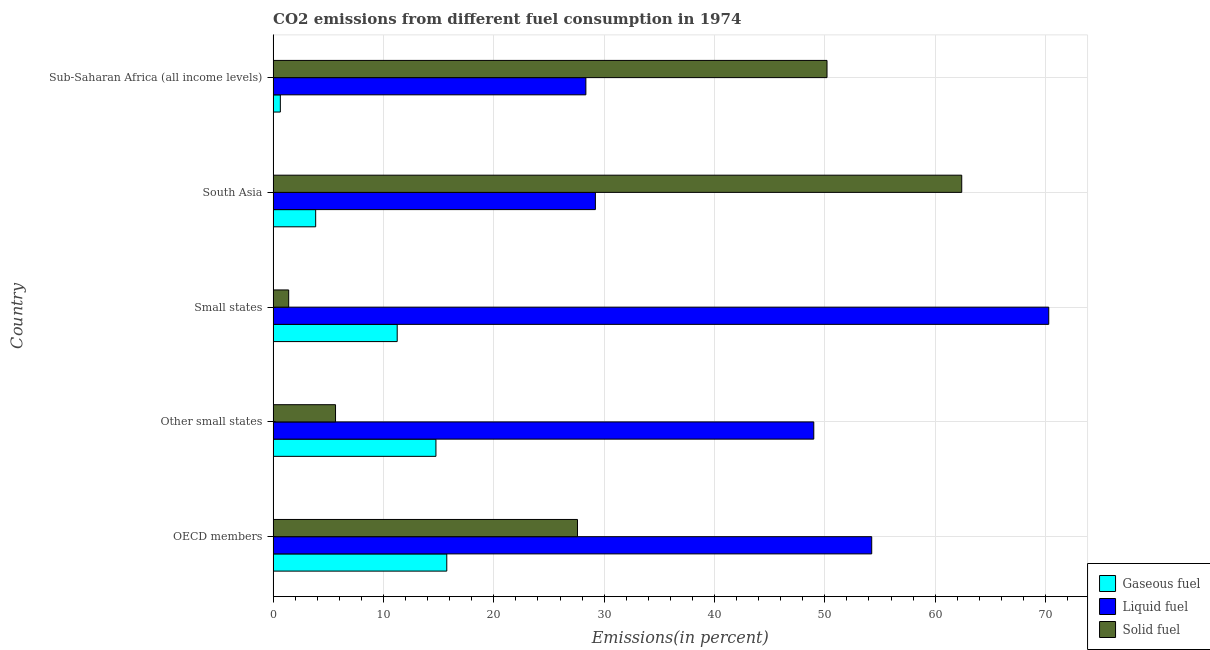How many different coloured bars are there?
Your response must be concise. 3. Are the number of bars per tick equal to the number of legend labels?
Your answer should be very brief. Yes. How many bars are there on the 3rd tick from the top?
Provide a short and direct response. 3. What is the label of the 4th group of bars from the top?
Make the answer very short. Other small states. What is the percentage of liquid fuel emission in Small states?
Your answer should be compact. 70.29. Across all countries, what is the maximum percentage of solid fuel emission?
Your answer should be very brief. 62.4. Across all countries, what is the minimum percentage of liquid fuel emission?
Your answer should be very brief. 28.34. In which country was the percentage of liquid fuel emission maximum?
Keep it short and to the point. Small states. In which country was the percentage of solid fuel emission minimum?
Offer a terse response. Small states. What is the total percentage of solid fuel emission in the graph?
Keep it short and to the point. 147.25. What is the difference between the percentage of liquid fuel emission in Small states and that in South Asia?
Ensure brevity in your answer.  41.09. What is the difference between the percentage of gaseous fuel emission in Small states and the percentage of solid fuel emission in Other small states?
Offer a very short reply. 5.59. What is the average percentage of liquid fuel emission per country?
Your response must be concise. 46.22. What is the difference between the percentage of liquid fuel emission and percentage of solid fuel emission in Sub-Saharan Africa (all income levels)?
Make the answer very short. -21.85. What is the ratio of the percentage of solid fuel emission in Other small states to that in South Asia?
Provide a succinct answer. 0.09. Is the percentage of liquid fuel emission in OECD members less than that in South Asia?
Give a very brief answer. No. Is the difference between the percentage of solid fuel emission in Other small states and Small states greater than the difference between the percentage of gaseous fuel emission in Other small states and Small states?
Offer a very short reply. Yes. What is the difference between the highest and the second highest percentage of liquid fuel emission?
Offer a very short reply. 16.04. What is the difference between the highest and the lowest percentage of solid fuel emission?
Your response must be concise. 60.99. In how many countries, is the percentage of solid fuel emission greater than the average percentage of solid fuel emission taken over all countries?
Your answer should be compact. 2. Is the sum of the percentage of liquid fuel emission in Small states and South Asia greater than the maximum percentage of gaseous fuel emission across all countries?
Give a very brief answer. Yes. What does the 3rd bar from the top in South Asia represents?
Your answer should be very brief. Gaseous fuel. What does the 1st bar from the bottom in South Asia represents?
Provide a succinct answer. Gaseous fuel. How many bars are there?
Ensure brevity in your answer.  15. What is the difference between two consecutive major ticks on the X-axis?
Provide a succinct answer. 10. Does the graph contain any zero values?
Give a very brief answer. No. What is the title of the graph?
Provide a short and direct response. CO2 emissions from different fuel consumption in 1974. Does "Renewable sources" appear as one of the legend labels in the graph?
Make the answer very short. No. What is the label or title of the X-axis?
Your answer should be very brief. Emissions(in percent). What is the label or title of the Y-axis?
Offer a very short reply. Country. What is the Emissions(in percent) of Gaseous fuel in OECD members?
Your answer should be very brief. 15.74. What is the Emissions(in percent) of Liquid fuel in OECD members?
Your answer should be very brief. 54.25. What is the Emissions(in percent) of Solid fuel in OECD members?
Provide a succinct answer. 27.58. What is the Emissions(in percent) of Gaseous fuel in Other small states?
Provide a succinct answer. 14.76. What is the Emissions(in percent) of Liquid fuel in Other small states?
Provide a short and direct response. 49. What is the Emissions(in percent) in Solid fuel in Other small states?
Your answer should be very brief. 5.66. What is the Emissions(in percent) in Gaseous fuel in Small states?
Provide a short and direct response. 11.25. What is the Emissions(in percent) in Liquid fuel in Small states?
Make the answer very short. 70.29. What is the Emissions(in percent) in Solid fuel in Small states?
Offer a very short reply. 1.41. What is the Emissions(in percent) in Gaseous fuel in South Asia?
Your answer should be compact. 3.86. What is the Emissions(in percent) of Liquid fuel in South Asia?
Keep it short and to the point. 29.21. What is the Emissions(in percent) in Solid fuel in South Asia?
Your response must be concise. 62.4. What is the Emissions(in percent) of Gaseous fuel in Sub-Saharan Africa (all income levels)?
Ensure brevity in your answer.  0.65. What is the Emissions(in percent) in Liquid fuel in Sub-Saharan Africa (all income levels)?
Your response must be concise. 28.34. What is the Emissions(in percent) in Solid fuel in Sub-Saharan Africa (all income levels)?
Your response must be concise. 50.2. Across all countries, what is the maximum Emissions(in percent) in Gaseous fuel?
Provide a short and direct response. 15.74. Across all countries, what is the maximum Emissions(in percent) of Liquid fuel?
Offer a terse response. 70.29. Across all countries, what is the maximum Emissions(in percent) in Solid fuel?
Keep it short and to the point. 62.4. Across all countries, what is the minimum Emissions(in percent) of Gaseous fuel?
Ensure brevity in your answer.  0.65. Across all countries, what is the minimum Emissions(in percent) in Liquid fuel?
Your response must be concise. 28.34. Across all countries, what is the minimum Emissions(in percent) of Solid fuel?
Keep it short and to the point. 1.41. What is the total Emissions(in percent) of Gaseous fuel in the graph?
Provide a succinct answer. 46.25. What is the total Emissions(in percent) in Liquid fuel in the graph?
Give a very brief answer. 231.09. What is the total Emissions(in percent) of Solid fuel in the graph?
Provide a short and direct response. 147.25. What is the difference between the Emissions(in percent) in Gaseous fuel in OECD members and that in Other small states?
Provide a succinct answer. 0.98. What is the difference between the Emissions(in percent) of Liquid fuel in OECD members and that in Other small states?
Your answer should be very brief. 5.25. What is the difference between the Emissions(in percent) of Solid fuel in OECD members and that in Other small states?
Make the answer very short. 21.93. What is the difference between the Emissions(in percent) of Gaseous fuel in OECD members and that in Small states?
Give a very brief answer. 4.49. What is the difference between the Emissions(in percent) of Liquid fuel in OECD members and that in Small states?
Provide a short and direct response. -16.04. What is the difference between the Emissions(in percent) in Solid fuel in OECD members and that in Small states?
Offer a terse response. 26.17. What is the difference between the Emissions(in percent) in Gaseous fuel in OECD members and that in South Asia?
Keep it short and to the point. 11.88. What is the difference between the Emissions(in percent) of Liquid fuel in OECD members and that in South Asia?
Provide a short and direct response. 25.04. What is the difference between the Emissions(in percent) of Solid fuel in OECD members and that in South Asia?
Offer a terse response. -34.82. What is the difference between the Emissions(in percent) of Gaseous fuel in OECD members and that in Sub-Saharan Africa (all income levels)?
Your response must be concise. 15.08. What is the difference between the Emissions(in percent) of Liquid fuel in OECD members and that in Sub-Saharan Africa (all income levels)?
Provide a short and direct response. 25.9. What is the difference between the Emissions(in percent) in Solid fuel in OECD members and that in Sub-Saharan Africa (all income levels)?
Offer a terse response. -22.61. What is the difference between the Emissions(in percent) in Gaseous fuel in Other small states and that in Small states?
Provide a succinct answer. 3.51. What is the difference between the Emissions(in percent) in Liquid fuel in Other small states and that in Small states?
Provide a short and direct response. -21.29. What is the difference between the Emissions(in percent) of Solid fuel in Other small states and that in Small states?
Provide a succinct answer. 4.25. What is the difference between the Emissions(in percent) of Gaseous fuel in Other small states and that in South Asia?
Provide a succinct answer. 10.9. What is the difference between the Emissions(in percent) of Liquid fuel in Other small states and that in South Asia?
Make the answer very short. 19.79. What is the difference between the Emissions(in percent) in Solid fuel in Other small states and that in South Asia?
Offer a very short reply. -56.75. What is the difference between the Emissions(in percent) in Gaseous fuel in Other small states and that in Sub-Saharan Africa (all income levels)?
Offer a very short reply. 14.1. What is the difference between the Emissions(in percent) of Liquid fuel in Other small states and that in Sub-Saharan Africa (all income levels)?
Provide a short and direct response. 20.65. What is the difference between the Emissions(in percent) in Solid fuel in Other small states and that in Sub-Saharan Africa (all income levels)?
Your response must be concise. -44.54. What is the difference between the Emissions(in percent) in Gaseous fuel in Small states and that in South Asia?
Offer a very short reply. 7.39. What is the difference between the Emissions(in percent) of Liquid fuel in Small states and that in South Asia?
Offer a very short reply. 41.09. What is the difference between the Emissions(in percent) of Solid fuel in Small states and that in South Asia?
Ensure brevity in your answer.  -60.99. What is the difference between the Emissions(in percent) in Gaseous fuel in Small states and that in Sub-Saharan Africa (all income levels)?
Make the answer very short. 10.59. What is the difference between the Emissions(in percent) in Liquid fuel in Small states and that in Sub-Saharan Africa (all income levels)?
Keep it short and to the point. 41.95. What is the difference between the Emissions(in percent) in Solid fuel in Small states and that in Sub-Saharan Africa (all income levels)?
Offer a very short reply. -48.79. What is the difference between the Emissions(in percent) of Gaseous fuel in South Asia and that in Sub-Saharan Africa (all income levels)?
Your response must be concise. 3.2. What is the difference between the Emissions(in percent) in Liquid fuel in South Asia and that in Sub-Saharan Africa (all income levels)?
Make the answer very short. 0.86. What is the difference between the Emissions(in percent) in Solid fuel in South Asia and that in Sub-Saharan Africa (all income levels)?
Offer a very short reply. 12.21. What is the difference between the Emissions(in percent) of Gaseous fuel in OECD members and the Emissions(in percent) of Liquid fuel in Other small states?
Ensure brevity in your answer.  -33.26. What is the difference between the Emissions(in percent) of Gaseous fuel in OECD members and the Emissions(in percent) of Solid fuel in Other small states?
Offer a very short reply. 10.08. What is the difference between the Emissions(in percent) in Liquid fuel in OECD members and the Emissions(in percent) in Solid fuel in Other small states?
Give a very brief answer. 48.59. What is the difference between the Emissions(in percent) in Gaseous fuel in OECD members and the Emissions(in percent) in Liquid fuel in Small states?
Offer a terse response. -54.55. What is the difference between the Emissions(in percent) of Gaseous fuel in OECD members and the Emissions(in percent) of Solid fuel in Small states?
Offer a terse response. 14.33. What is the difference between the Emissions(in percent) in Liquid fuel in OECD members and the Emissions(in percent) in Solid fuel in Small states?
Your response must be concise. 52.84. What is the difference between the Emissions(in percent) of Gaseous fuel in OECD members and the Emissions(in percent) of Liquid fuel in South Asia?
Offer a very short reply. -13.47. What is the difference between the Emissions(in percent) in Gaseous fuel in OECD members and the Emissions(in percent) in Solid fuel in South Asia?
Your answer should be very brief. -46.67. What is the difference between the Emissions(in percent) in Liquid fuel in OECD members and the Emissions(in percent) in Solid fuel in South Asia?
Provide a short and direct response. -8.16. What is the difference between the Emissions(in percent) of Gaseous fuel in OECD members and the Emissions(in percent) of Liquid fuel in Sub-Saharan Africa (all income levels)?
Make the answer very short. -12.61. What is the difference between the Emissions(in percent) of Gaseous fuel in OECD members and the Emissions(in percent) of Solid fuel in Sub-Saharan Africa (all income levels)?
Offer a terse response. -34.46. What is the difference between the Emissions(in percent) of Liquid fuel in OECD members and the Emissions(in percent) of Solid fuel in Sub-Saharan Africa (all income levels)?
Give a very brief answer. 4.05. What is the difference between the Emissions(in percent) in Gaseous fuel in Other small states and the Emissions(in percent) in Liquid fuel in Small states?
Offer a very short reply. -55.54. What is the difference between the Emissions(in percent) of Gaseous fuel in Other small states and the Emissions(in percent) of Solid fuel in Small states?
Provide a succinct answer. 13.35. What is the difference between the Emissions(in percent) in Liquid fuel in Other small states and the Emissions(in percent) in Solid fuel in Small states?
Your answer should be very brief. 47.59. What is the difference between the Emissions(in percent) in Gaseous fuel in Other small states and the Emissions(in percent) in Liquid fuel in South Asia?
Your answer should be compact. -14.45. What is the difference between the Emissions(in percent) in Gaseous fuel in Other small states and the Emissions(in percent) in Solid fuel in South Asia?
Provide a short and direct response. -47.65. What is the difference between the Emissions(in percent) in Liquid fuel in Other small states and the Emissions(in percent) in Solid fuel in South Asia?
Make the answer very short. -13.41. What is the difference between the Emissions(in percent) of Gaseous fuel in Other small states and the Emissions(in percent) of Liquid fuel in Sub-Saharan Africa (all income levels)?
Provide a succinct answer. -13.59. What is the difference between the Emissions(in percent) of Gaseous fuel in Other small states and the Emissions(in percent) of Solid fuel in Sub-Saharan Africa (all income levels)?
Your response must be concise. -35.44. What is the difference between the Emissions(in percent) in Liquid fuel in Other small states and the Emissions(in percent) in Solid fuel in Sub-Saharan Africa (all income levels)?
Offer a terse response. -1.2. What is the difference between the Emissions(in percent) in Gaseous fuel in Small states and the Emissions(in percent) in Liquid fuel in South Asia?
Provide a short and direct response. -17.96. What is the difference between the Emissions(in percent) in Gaseous fuel in Small states and the Emissions(in percent) in Solid fuel in South Asia?
Your response must be concise. -51.16. What is the difference between the Emissions(in percent) in Liquid fuel in Small states and the Emissions(in percent) in Solid fuel in South Asia?
Keep it short and to the point. 7.89. What is the difference between the Emissions(in percent) of Gaseous fuel in Small states and the Emissions(in percent) of Liquid fuel in Sub-Saharan Africa (all income levels)?
Make the answer very short. -17.1. What is the difference between the Emissions(in percent) in Gaseous fuel in Small states and the Emissions(in percent) in Solid fuel in Sub-Saharan Africa (all income levels)?
Your answer should be compact. -38.95. What is the difference between the Emissions(in percent) in Liquid fuel in Small states and the Emissions(in percent) in Solid fuel in Sub-Saharan Africa (all income levels)?
Ensure brevity in your answer.  20.1. What is the difference between the Emissions(in percent) in Gaseous fuel in South Asia and the Emissions(in percent) in Liquid fuel in Sub-Saharan Africa (all income levels)?
Give a very brief answer. -24.49. What is the difference between the Emissions(in percent) in Gaseous fuel in South Asia and the Emissions(in percent) in Solid fuel in Sub-Saharan Africa (all income levels)?
Make the answer very short. -46.34. What is the difference between the Emissions(in percent) of Liquid fuel in South Asia and the Emissions(in percent) of Solid fuel in Sub-Saharan Africa (all income levels)?
Provide a succinct answer. -20.99. What is the average Emissions(in percent) in Gaseous fuel per country?
Your answer should be compact. 9.25. What is the average Emissions(in percent) of Liquid fuel per country?
Give a very brief answer. 46.22. What is the average Emissions(in percent) in Solid fuel per country?
Offer a terse response. 29.45. What is the difference between the Emissions(in percent) of Gaseous fuel and Emissions(in percent) of Liquid fuel in OECD members?
Your answer should be compact. -38.51. What is the difference between the Emissions(in percent) in Gaseous fuel and Emissions(in percent) in Solid fuel in OECD members?
Provide a succinct answer. -11.85. What is the difference between the Emissions(in percent) in Liquid fuel and Emissions(in percent) in Solid fuel in OECD members?
Ensure brevity in your answer.  26.66. What is the difference between the Emissions(in percent) of Gaseous fuel and Emissions(in percent) of Liquid fuel in Other small states?
Give a very brief answer. -34.24. What is the difference between the Emissions(in percent) of Gaseous fuel and Emissions(in percent) of Solid fuel in Other small states?
Ensure brevity in your answer.  9.1. What is the difference between the Emissions(in percent) in Liquid fuel and Emissions(in percent) in Solid fuel in Other small states?
Your answer should be very brief. 43.34. What is the difference between the Emissions(in percent) of Gaseous fuel and Emissions(in percent) of Liquid fuel in Small states?
Your answer should be compact. -59.05. What is the difference between the Emissions(in percent) of Gaseous fuel and Emissions(in percent) of Solid fuel in Small states?
Your answer should be very brief. 9.83. What is the difference between the Emissions(in percent) in Liquid fuel and Emissions(in percent) in Solid fuel in Small states?
Make the answer very short. 68.88. What is the difference between the Emissions(in percent) in Gaseous fuel and Emissions(in percent) in Liquid fuel in South Asia?
Ensure brevity in your answer.  -25.35. What is the difference between the Emissions(in percent) of Gaseous fuel and Emissions(in percent) of Solid fuel in South Asia?
Keep it short and to the point. -58.55. What is the difference between the Emissions(in percent) of Liquid fuel and Emissions(in percent) of Solid fuel in South Asia?
Your response must be concise. -33.2. What is the difference between the Emissions(in percent) of Gaseous fuel and Emissions(in percent) of Liquid fuel in Sub-Saharan Africa (all income levels)?
Make the answer very short. -27.69. What is the difference between the Emissions(in percent) in Gaseous fuel and Emissions(in percent) in Solid fuel in Sub-Saharan Africa (all income levels)?
Your answer should be very brief. -49.54. What is the difference between the Emissions(in percent) in Liquid fuel and Emissions(in percent) in Solid fuel in Sub-Saharan Africa (all income levels)?
Provide a short and direct response. -21.85. What is the ratio of the Emissions(in percent) in Gaseous fuel in OECD members to that in Other small states?
Your response must be concise. 1.07. What is the ratio of the Emissions(in percent) in Liquid fuel in OECD members to that in Other small states?
Give a very brief answer. 1.11. What is the ratio of the Emissions(in percent) of Solid fuel in OECD members to that in Other small states?
Provide a short and direct response. 4.88. What is the ratio of the Emissions(in percent) of Gaseous fuel in OECD members to that in Small states?
Offer a terse response. 1.4. What is the ratio of the Emissions(in percent) of Liquid fuel in OECD members to that in Small states?
Offer a terse response. 0.77. What is the ratio of the Emissions(in percent) of Solid fuel in OECD members to that in Small states?
Keep it short and to the point. 19.56. What is the ratio of the Emissions(in percent) in Gaseous fuel in OECD members to that in South Asia?
Offer a terse response. 4.08. What is the ratio of the Emissions(in percent) of Liquid fuel in OECD members to that in South Asia?
Keep it short and to the point. 1.86. What is the ratio of the Emissions(in percent) of Solid fuel in OECD members to that in South Asia?
Ensure brevity in your answer.  0.44. What is the ratio of the Emissions(in percent) in Gaseous fuel in OECD members to that in Sub-Saharan Africa (all income levels)?
Your answer should be very brief. 24.07. What is the ratio of the Emissions(in percent) of Liquid fuel in OECD members to that in Sub-Saharan Africa (all income levels)?
Make the answer very short. 1.91. What is the ratio of the Emissions(in percent) in Solid fuel in OECD members to that in Sub-Saharan Africa (all income levels)?
Make the answer very short. 0.55. What is the ratio of the Emissions(in percent) in Gaseous fuel in Other small states to that in Small states?
Make the answer very short. 1.31. What is the ratio of the Emissions(in percent) in Liquid fuel in Other small states to that in Small states?
Offer a terse response. 0.7. What is the ratio of the Emissions(in percent) of Solid fuel in Other small states to that in Small states?
Give a very brief answer. 4.01. What is the ratio of the Emissions(in percent) of Gaseous fuel in Other small states to that in South Asia?
Your answer should be very brief. 3.83. What is the ratio of the Emissions(in percent) in Liquid fuel in Other small states to that in South Asia?
Provide a succinct answer. 1.68. What is the ratio of the Emissions(in percent) of Solid fuel in Other small states to that in South Asia?
Keep it short and to the point. 0.09. What is the ratio of the Emissions(in percent) in Gaseous fuel in Other small states to that in Sub-Saharan Africa (all income levels)?
Provide a short and direct response. 22.57. What is the ratio of the Emissions(in percent) of Liquid fuel in Other small states to that in Sub-Saharan Africa (all income levels)?
Provide a short and direct response. 1.73. What is the ratio of the Emissions(in percent) of Solid fuel in Other small states to that in Sub-Saharan Africa (all income levels)?
Give a very brief answer. 0.11. What is the ratio of the Emissions(in percent) of Gaseous fuel in Small states to that in South Asia?
Ensure brevity in your answer.  2.92. What is the ratio of the Emissions(in percent) of Liquid fuel in Small states to that in South Asia?
Your response must be concise. 2.41. What is the ratio of the Emissions(in percent) in Solid fuel in Small states to that in South Asia?
Provide a short and direct response. 0.02. What is the ratio of the Emissions(in percent) in Gaseous fuel in Small states to that in Sub-Saharan Africa (all income levels)?
Provide a succinct answer. 17.2. What is the ratio of the Emissions(in percent) in Liquid fuel in Small states to that in Sub-Saharan Africa (all income levels)?
Ensure brevity in your answer.  2.48. What is the ratio of the Emissions(in percent) of Solid fuel in Small states to that in Sub-Saharan Africa (all income levels)?
Your response must be concise. 0.03. What is the ratio of the Emissions(in percent) of Gaseous fuel in South Asia to that in Sub-Saharan Africa (all income levels)?
Your answer should be compact. 5.9. What is the ratio of the Emissions(in percent) in Liquid fuel in South Asia to that in Sub-Saharan Africa (all income levels)?
Give a very brief answer. 1.03. What is the ratio of the Emissions(in percent) of Solid fuel in South Asia to that in Sub-Saharan Africa (all income levels)?
Provide a succinct answer. 1.24. What is the difference between the highest and the second highest Emissions(in percent) in Gaseous fuel?
Make the answer very short. 0.98. What is the difference between the highest and the second highest Emissions(in percent) in Liquid fuel?
Your response must be concise. 16.04. What is the difference between the highest and the second highest Emissions(in percent) of Solid fuel?
Give a very brief answer. 12.21. What is the difference between the highest and the lowest Emissions(in percent) in Gaseous fuel?
Offer a terse response. 15.08. What is the difference between the highest and the lowest Emissions(in percent) of Liquid fuel?
Offer a terse response. 41.95. What is the difference between the highest and the lowest Emissions(in percent) in Solid fuel?
Give a very brief answer. 60.99. 